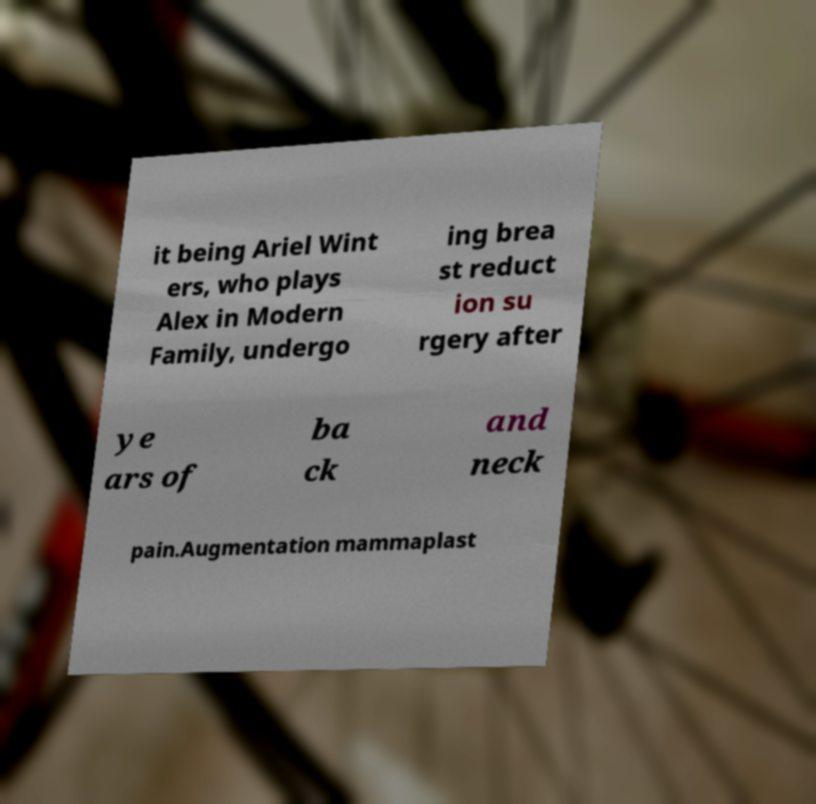Please read and relay the text visible in this image. What does it say? it being Ariel Wint ers, who plays Alex in Modern Family, undergo ing brea st reduct ion su rgery after ye ars of ba ck and neck pain.Augmentation mammaplast 